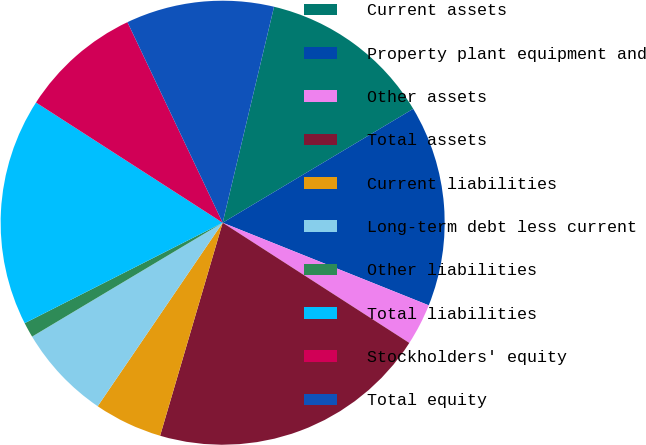<chart> <loc_0><loc_0><loc_500><loc_500><pie_chart><fcel>Current assets<fcel>Property plant equipment and<fcel>Other assets<fcel>Total assets<fcel>Current liabilities<fcel>Long-term debt less current<fcel>Other liabilities<fcel>Total liabilities<fcel>Stockholders' equity<fcel>Total equity<nl><fcel>12.71%<fcel>14.64%<fcel>3.04%<fcel>20.44%<fcel>4.97%<fcel>6.91%<fcel>1.1%<fcel>16.58%<fcel>8.84%<fcel>10.77%<nl></chart> 